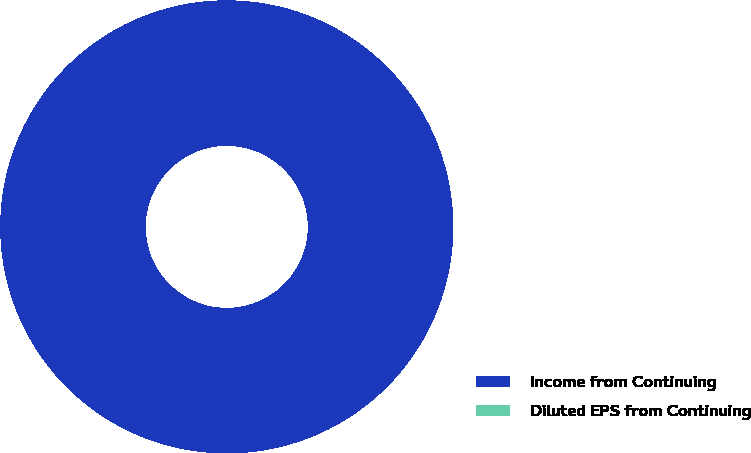Convert chart to OTSL. <chart><loc_0><loc_0><loc_500><loc_500><pie_chart><fcel>Income from Continuing<fcel>Diluted EPS from Continuing<nl><fcel>100.0%<fcel>0.0%<nl></chart> 